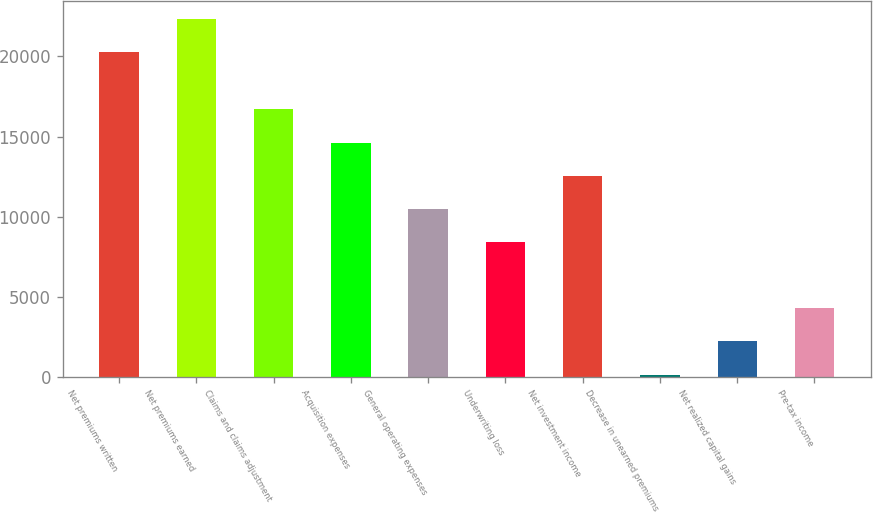<chart> <loc_0><loc_0><loc_500><loc_500><bar_chart><fcel>Net premiums written<fcel>Net premiums earned<fcel>Claims and claims adjustment<fcel>Acquisition expenses<fcel>General operating expenses<fcel>Underwriting loss<fcel>Net investment income<fcel>Decrease in unearned premiums<fcel>Net realized capital gains<fcel>Pre-tax income<nl><fcel>20300<fcel>22366.5<fcel>16696<fcel>14600.5<fcel>10467.5<fcel>8401<fcel>12534<fcel>135<fcel>2201.5<fcel>4268<nl></chart> 